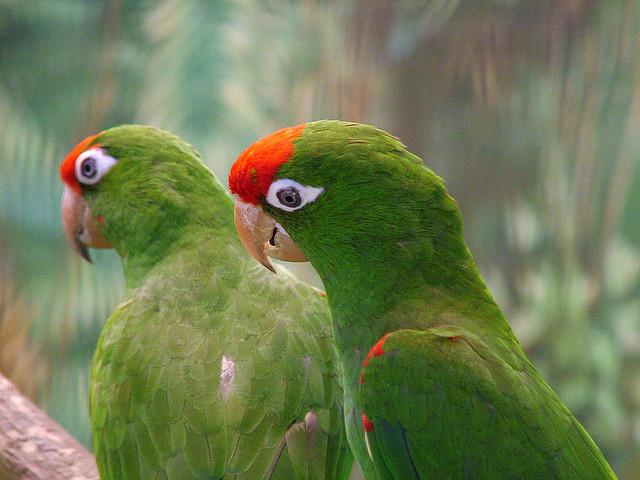Do these birds crack nuts?
Answer briefly. Yes. What colors are the birds?
Keep it brief. Green. How many bird are in the photo?
Short answer required. 2. 